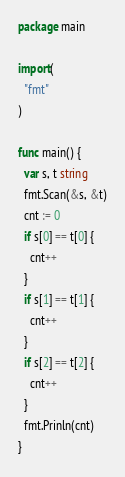Convert code to text. <code><loc_0><loc_0><loc_500><loc_500><_Go_>package main

import(
  "fmt"
)

func main() {
  var s, t string
  fmt.Scan(&s, &t)
  cnt := 0
  if s[0] == t[0] {
    cnt++
  }
  if s[1] == t[1] {
    cnt++
  }
  if s[2] == t[2] {
    cnt++
  }
  fmt.Prinln(cnt)
}
</code> 